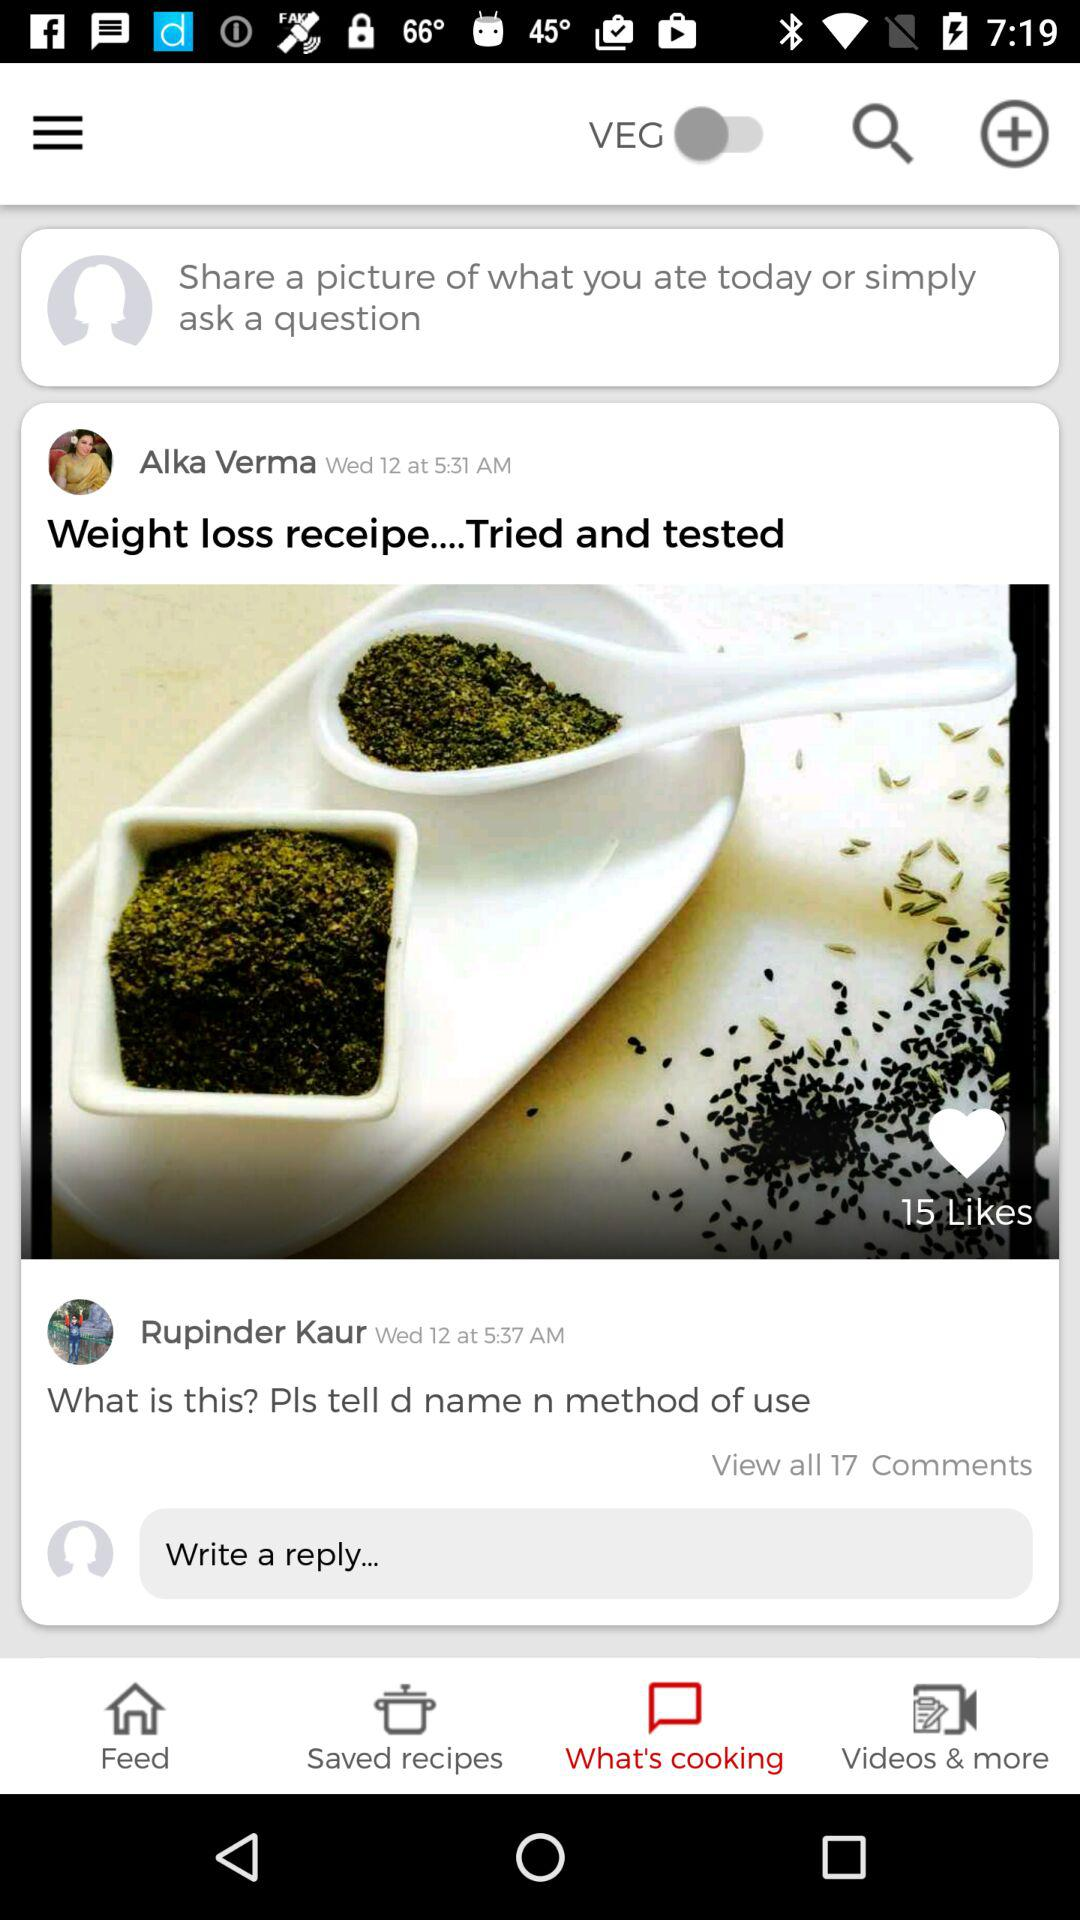How many comments are there?
Answer the question using a single word or phrase. 17 